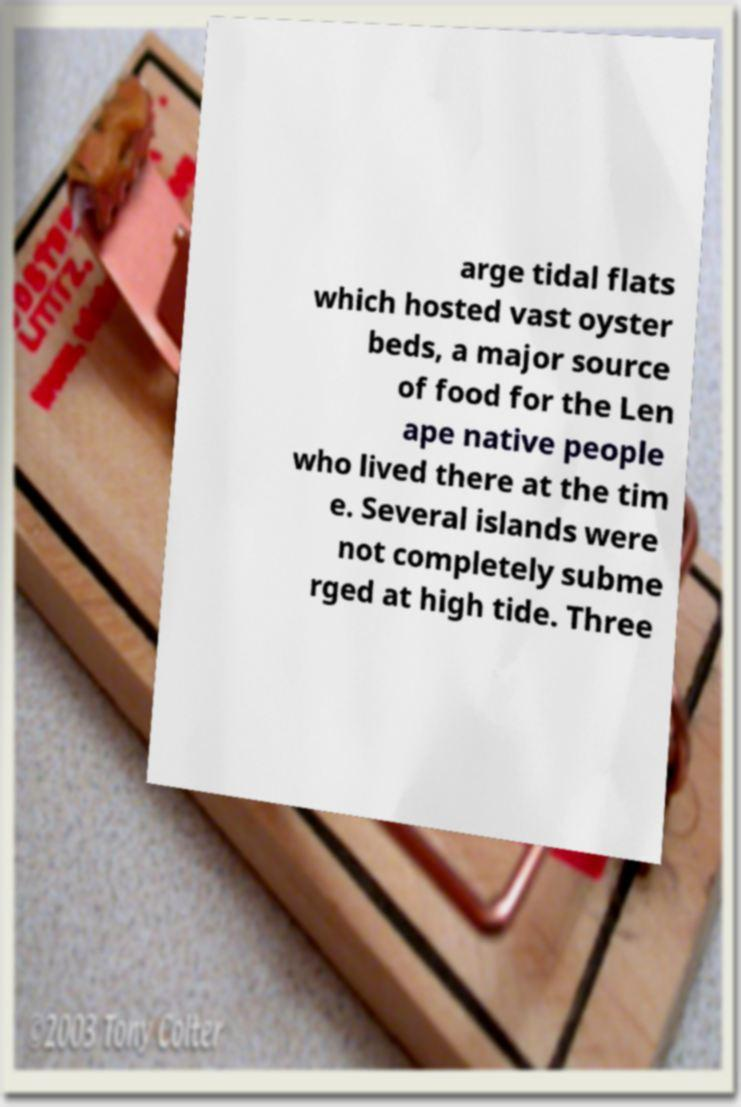For documentation purposes, I need the text within this image transcribed. Could you provide that? arge tidal flats which hosted vast oyster beds, a major source of food for the Len ape native people who lived there at the tim e. Several islands were not completely subme rged at high tide. Three 